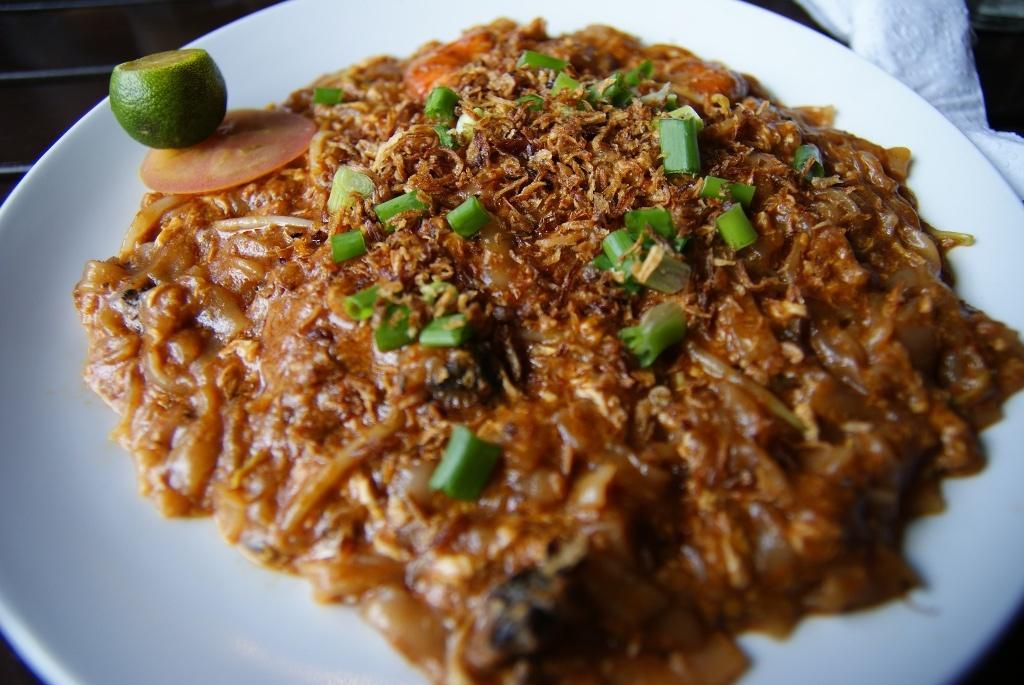How would you summarize this image in a sentence or two? In the image we can see there is a food item kept on the plate. There is a slice of tomato and lemon kept on the plate. 